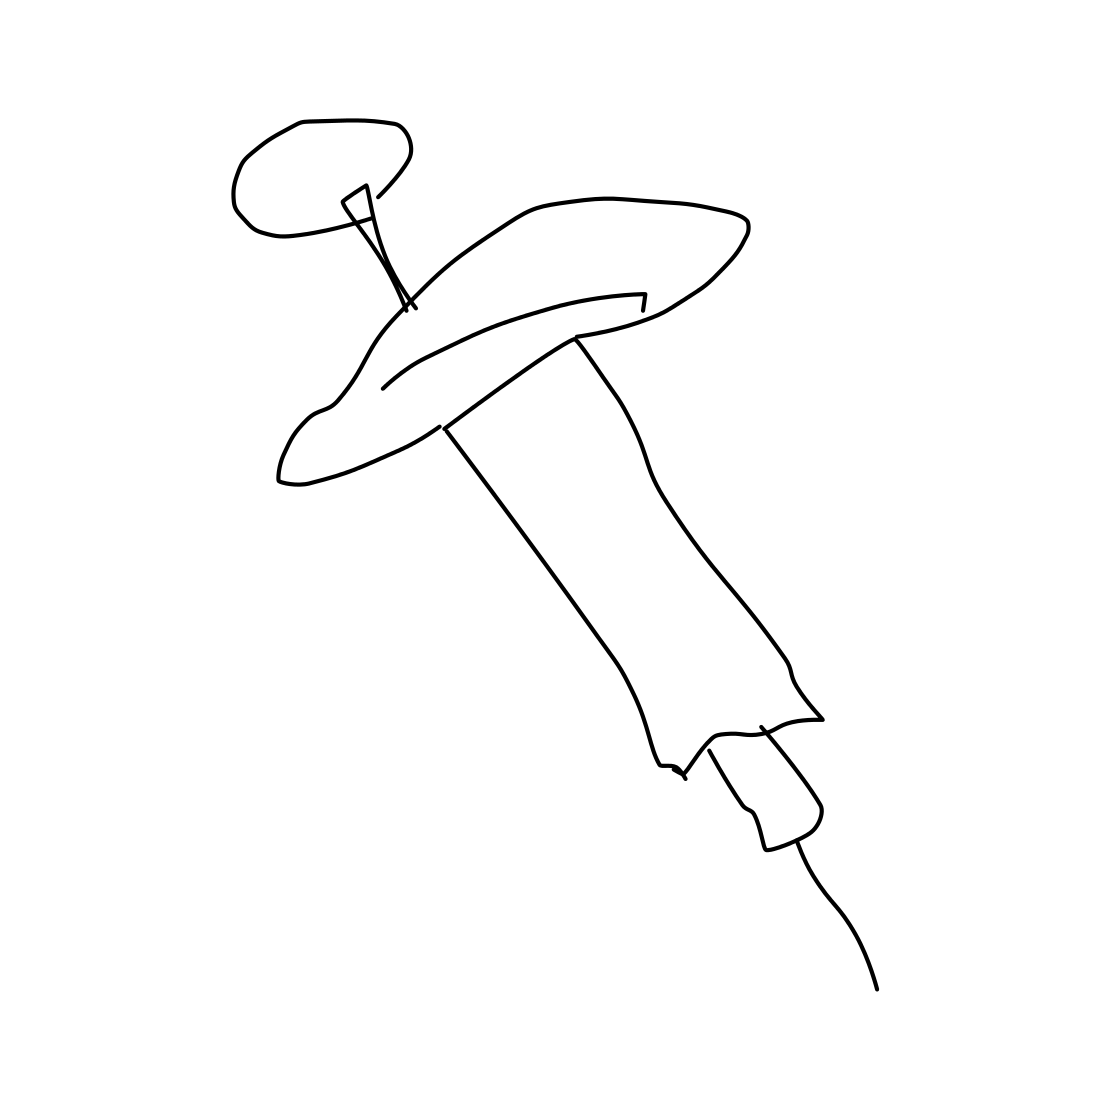Can you tell me if this syringe is meant for a specific age group? The image doesn't provide enough context to determine if the syringe is meant for a specific age group. In general, syringes like this one can be used across different age groups, adjusted for dosage as necessary based on a patient's needs. 